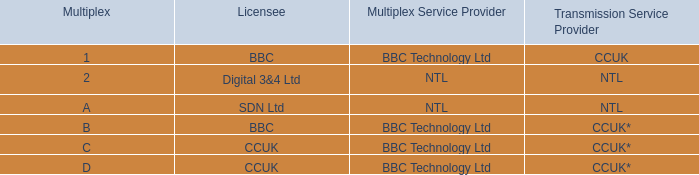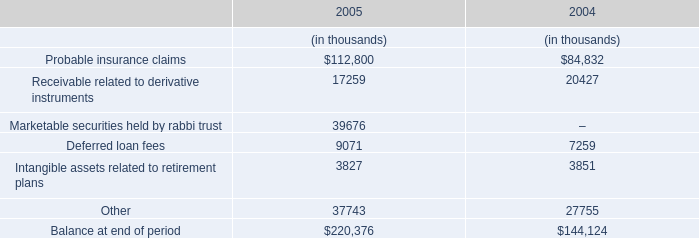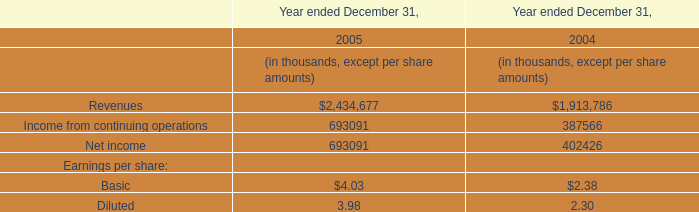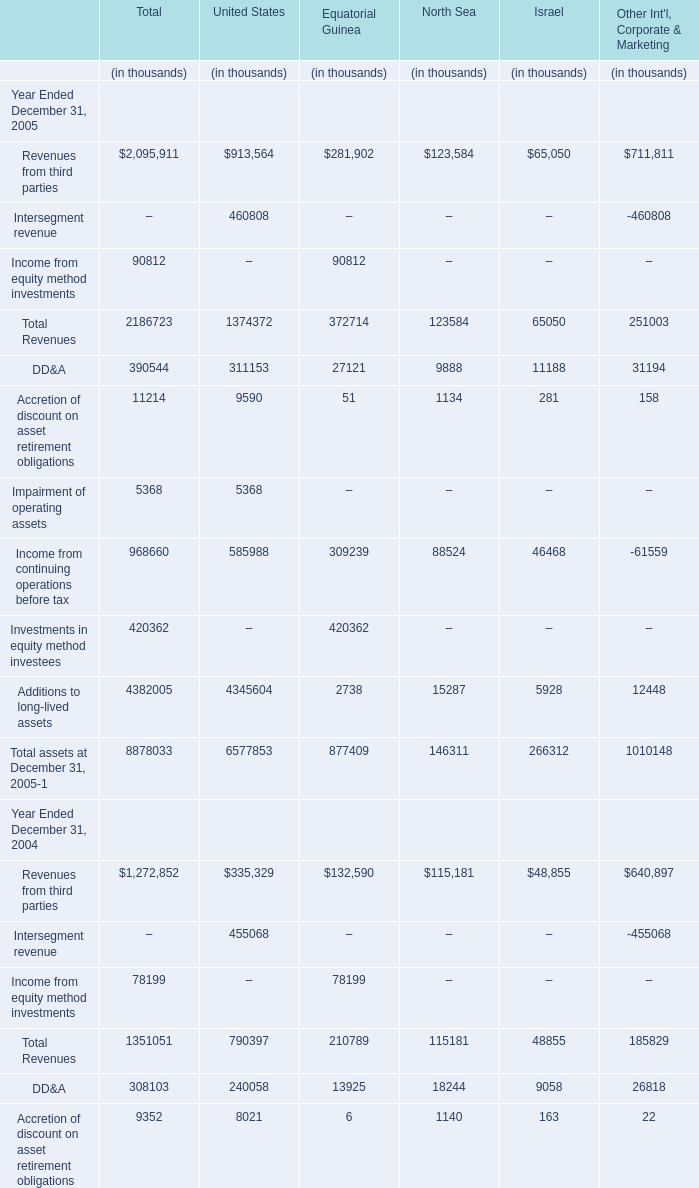Does the value of Revenues from third parties for Equatorial Guinea greater than that inUnited States? 
Answer: no. 